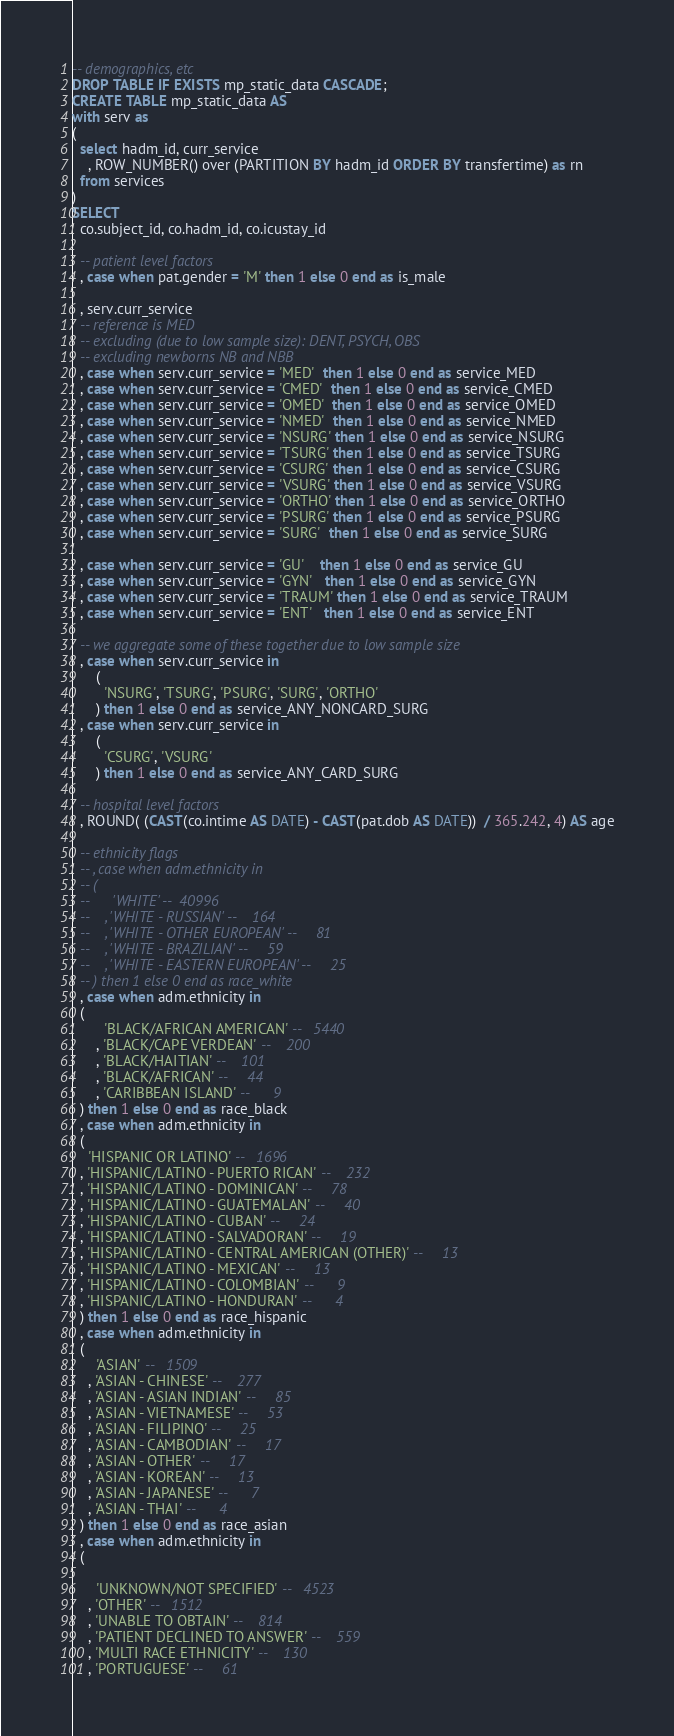Convert code to text. <code><loc_0><loc_0><loc_500><loc_500><_SQL_>-- demographics, etc
DROP TABLE IF EXISTS mp_static_data CASCADE;
CREATE TABLE mp_static_data AS
with serv as
(
  select hadm_id, curr_service
    , ROW_NUMBER() over (PARTITION BY hadm_id ORDER BY transfertime) as rn
  from services
)
SELECT
  co.subject_id, co.hadm_id, co.icustay_id

  -- patient level factors
  , case when pat.gender = 'M' then 1 else 0 end as is_male

  , serv.curr_service
  -- reference is MED
  -- excluding (due to low sample size): DENT, PSYCH, OBS
  -- excluding newborns NB and NBB
  , case when serv.curr_service = 'MED'  then 1 else 0 end as service_MED
  , case when serv.curr_service = 'CMED'  then 1 else 0 end as service_CMED
  , case when serv.curr_service = 'OMED'  then 1 else 0 end as service_OMED
  , case when serv.curr_service = 'NMED'  then 1 else 0 end as service_NMED
  , case when serv.curr_service = 'NSURG' then 1 else 0 end as service_NSURG
  , case when serv.curr_service = 'TSURG' then 1 else 0 end as service_TSURG
  , case when serv.curr_service = 'CSURG' then 1 else 0 end as service_CSURG
  , case when serv.curr_service = 'VSURG' then 1 else 0 end as service_VSURG
  , case when serv.curr_service = 'ORTHO' then 1 else 0 end as service_ORTHO
  , case when serv.curr_service = 'PSURG' then 1 else 0 end as service_PSURG
  , case when serv.curr_service = 'SURG'  then 1 else 0 end as service_SURG

  , case when serv.curr_service = 'GU'    then 1 else 0 end as service_GU
  , case when serv.curr_service = 'GYN'   then 1 else 0 end as service_GYN
  , case when serv.curr_service = 'TRAUM' then 1 else 0 end as service_TRAUM
  , case when serv.curr_service = 'ENT'   then 1 else 0 end as service_ENT

  -- we aggregate some of these together due to low sample size
  , case when serv.curr_service in
      (
        'NSURG', 'TSURG', 'PSURG', 'SURG', 'ORTHO'
      ) then 1 else 0 end as service_ANY_NONCARD_SURG
  , case when serv.curr_service in
      (
        'CSURG', 'VSURG'
      ) then 1 else 0 end as service_ANY_CARD_SURG

  -- hospital level factors
  , ROUND( (CAST(co.intime AS DATE) - CAST(pat.dob AS DATE))  / 365.242, 4) AS age

  -- ethnicity flags
  -- , case when adm.ethnicity in
  -- (
  --      'WHITE' --  40996
  --    , 'WHITE - RUSSIAN' --    164
  --    , 'WHITE - OTHER EUROPEAN' --     81
  --    , 'WHITE - BRAZILIAN' --     59
  --    , 'WHITE - EASTERN EUROPEAN' --     25
  -- ) then 1 else 0 end as race_white
  , case when adm.ethnicity in
  (
        'BLACK/AFRICAN AMERICAN' --   5440
      , 'BLACK/CAPE VERDEAN' --    200
      , 'BLACK/HAITIAN' --    101
      , 'BLACK/AFRICAN' --     44
      , 'CARIBBEAN ISLAND' --      9
  ) then 1 else 0 end as race_black
  , case when adm.ethnicity in
  (
    'HISPANIC OR LATINO' --   1696
  , 'HISPANIC/LATINO - PUERTO RICAN' --    232
  , 'HISPANIC/LATINO - DOMINICAN' --     78
  , 'HISPANIC/LATINO - GUATEMALAN' --     40
  , 'HISPANIC/LATINO - CUBAN' --     24
  , 'HISPANIC/LATINO - SALVADORAN' --     19
  , 'HISPANIC/LATINO - CENTRAL AMERICAN (OTHER)' --     13
  , 'HISPANIC/LATINO - MEXICAN' --     13
  , 'HISPANIC/LATINO - COLOMBIAN' --      9
  , 'HISPANIC/LATINO - HONDURAN' --      4
  ) then 1 else 0 end as race_hispanic
  , case when adm.ethnicity in
  (
      'ASIAN' --   1509
    , 'ASIAN - CHINESE' --    277
    , 'ASIAN - ASIAN INDIAN' --     85
    , 'ASIAN - VIETNAMESE' --     53
    , 'ASIAN - FILIPINO' --     25
    , 'ASIAN - CAMBODIAN' --     17
    , 'ASIAN - OTHER' --     17
    , 'ASIAN - KOREAN' --     13
    , 'ASIAN - JAPANESE' --      7
    , 'ASIAN - THAI' --      4
  ) then 1 else 0 end as race_asian
  , case when adm.ethnicity in
  (

      'UNKNOWN/NOT SPECIFIED' --   4523
    , 'OTHER' --   1512
    , 'UNABLE TO OBTAIN' --    814
    , 'PATIENT DECLINED TO ANSWER' --    559
    , 'MULTI RACE ETHNICITY' --    130
    , 'PORTUGUESE' --     61</code> 